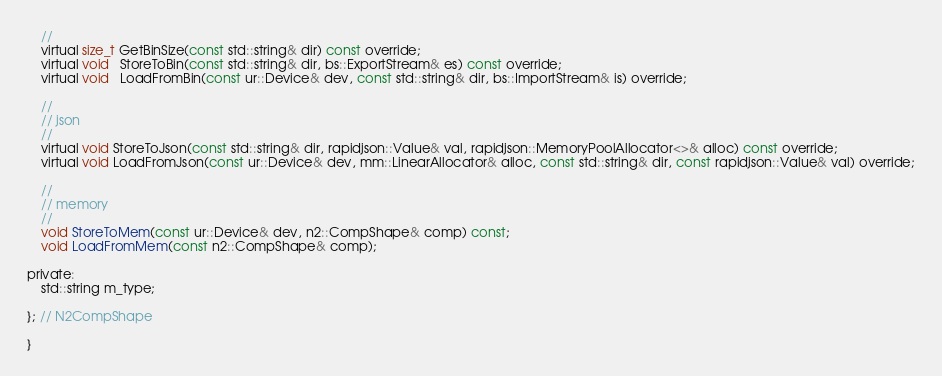<code> <loc_0><loc_0><loc_500><loc_500><_C_>	//
	virtual size_t GetBinSize(const std::string& dir) const override;
	virtual void   StoreToBin(const std::string& dir, bs::ExportStream& es) const override;
	virtual void   LoadFromBin(const ur::Device& dev, const std::string& dir, bs::ImportStream& is) override;

	//
	// json
	//
	virtual void StoreToJson(const std::string& dir, rapidjson::Value& val, rapidjson::MemoryPoolAllocator<>& alloc) const override;
	virtual void LoadFromJson(const ur::Device& dev, mm::LinearAllocator& alloc, const std::string& dir, const rapidjson::Value& val) override;

	//
	// memory
	//
	void StoreToMem(const ur::Device& dev, n2::CompShape& comp) const;
	void LoadFromMem(const n2::CompShape& comp);

private:
	std::string m_type;

}; // N2CompShape

}</code> 